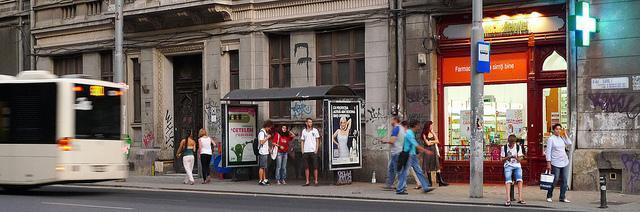How many people are waiting at the bus station?
Give a very brief answer. 3. How many non-red buses are in the street?
Give a very brief answer. 1. How many clocks on the building?
Give a very brief answer. 0. 